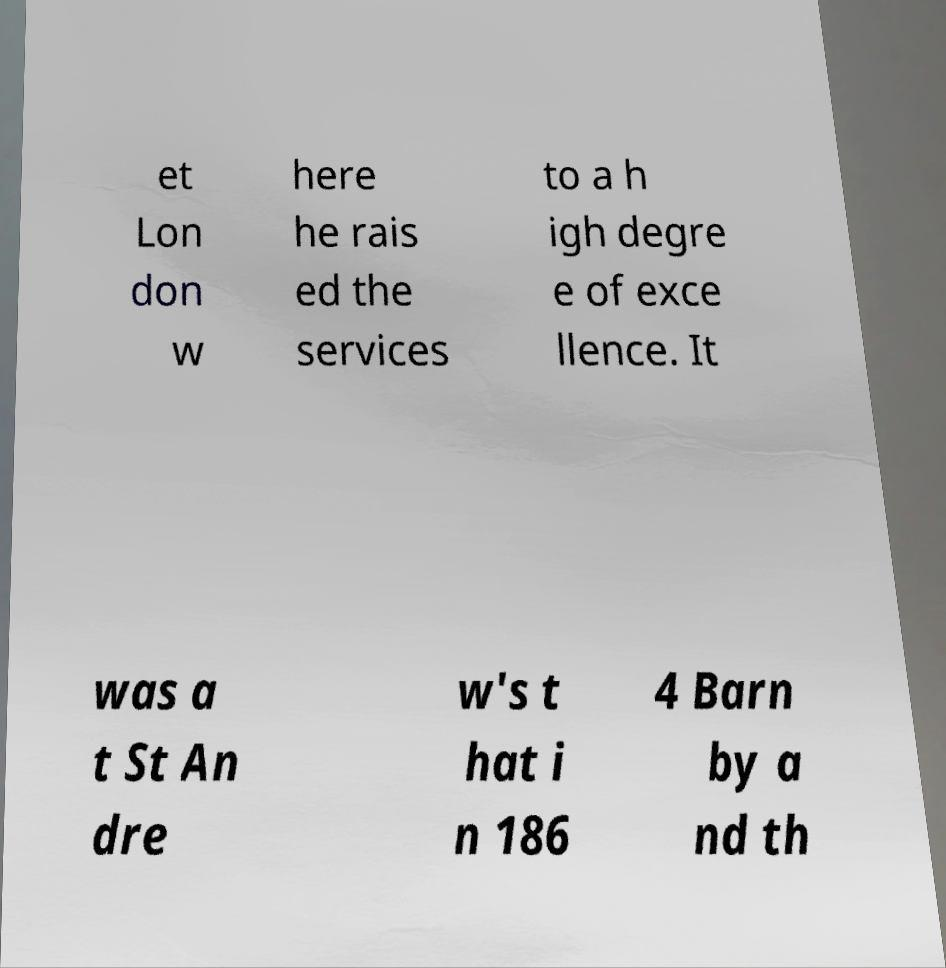Please read and relay the text visible in this image. What does it say? et Lon don w here he rais ed the services to a h igh degre e of exce llence. It was a t St An dre w's t hat i n 186 4 Barn by a nd th 